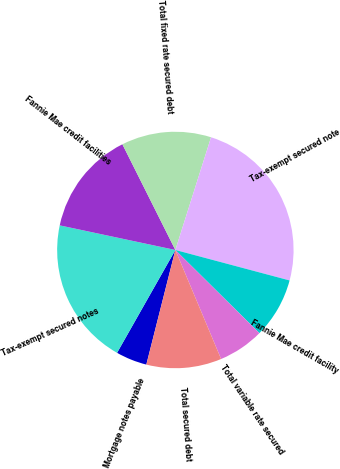<chart> <loc_0><loc_0><loc_500><loc_500><pie_chart><fcel>Mortgage notes payable<fcel>Tax-exempt secured notes<fcel>Fannie Mae credit facilities<fcel>Total fixed rate secured debt<fcel>Tax-exempt secured note<fcel>Fannie Mae credit facility<fcel>Total variable rate secured<fcel>Total secured debt<nl><fcel>4.26%<fcel>20.13%<fcel>14.27%<fcel>12.27%<fcel>24.27%<fcel>8.27%<fcel>6.26%<fcel>10.27%<nl></chart> 